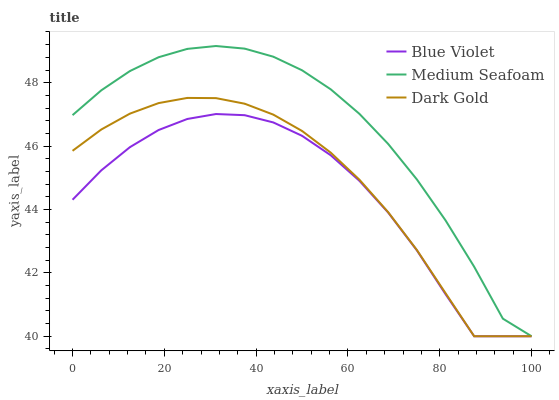Does Blue Violet have the minimum area under the curve?
Answer yes or no. Yes. Does Medium Seafoam have the maximum area under the curve?
Answer yes or no. Yes. Does Dark Gold have the minimum area under the curve?
Answer yes or no. No. Does Dark Gold have the maximum area under the curve?
Answer yes or no. No. Is Dark Gold the smoothest?
Answer yes or no. Yes. Is Blue Violet the roughest?
Answer yes or no. Yes. Is Blue Violet the smoothest?
Answer yes or no. No. Is Dark Gold the roughest?
Answer yes or no. No. Does Medium Seafoam have the lowest value?
Answer yes or no. Yes. Does Medium Seafoam have the highest value?
Answer yes or no. Yes. Does Dark Gold have the highest value?
Answer yes or no. No. Does Medium Seafoam intersect Dark Gold?
Answer yes or no. Yes. Is Medium Seafoam less than Dark Gold?
Answer yes or no. No. Is Medium Seafoam greater than Dark Gold?
Answer yes or no. No. 